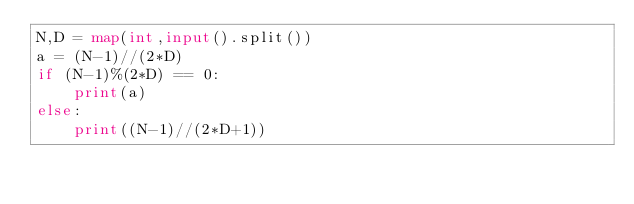Convert code to text. <code><loc_0><loc_0><loc_500><loc_500><_Python_>N,D = map(int,input().split())
a = (N-1)//(2*D)
if (N-1)%(2*D) == 0:
	print(a)
else:
 	print((N-1)//(2*D+1))
</code> 